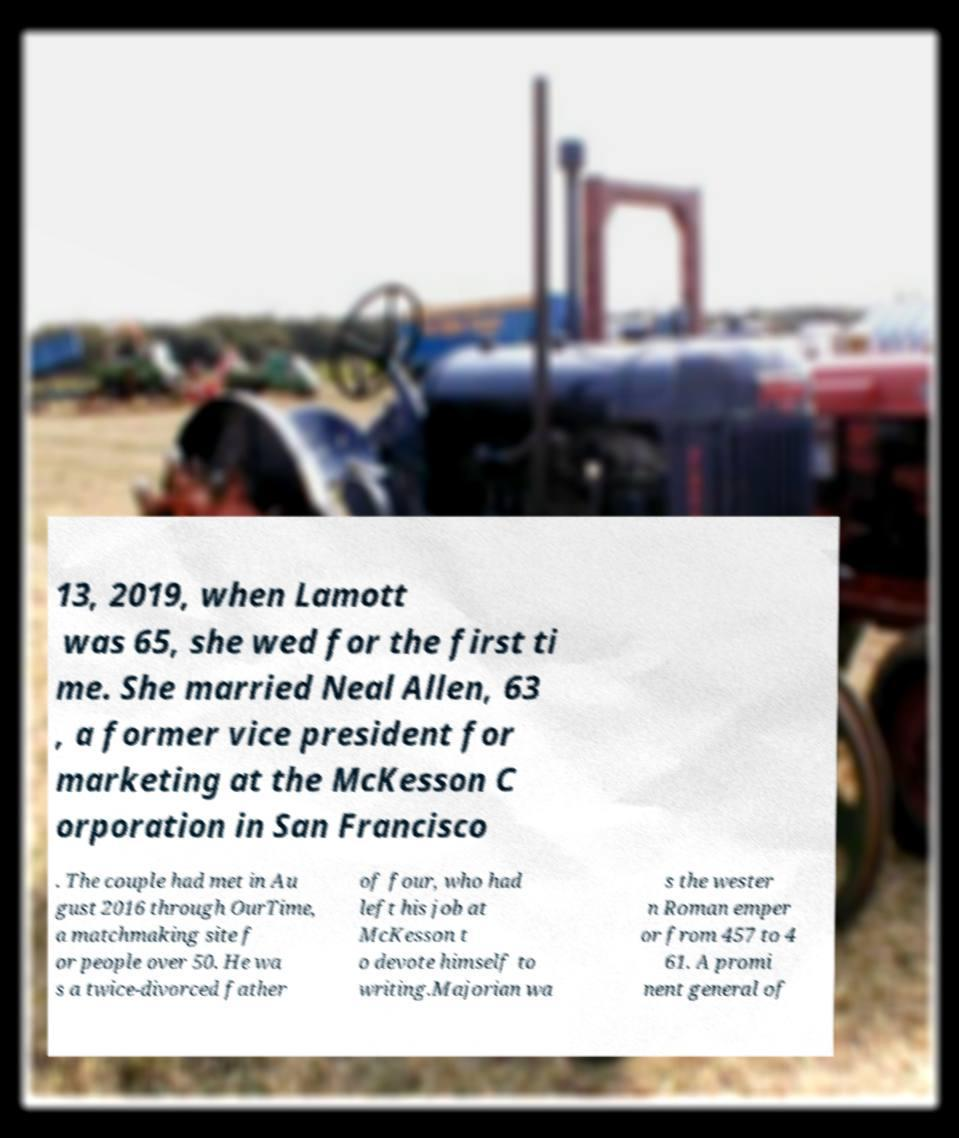Could you assist in decoding the text presented in this image and type it out clearly? 13, 2019, when Lamott was 65, she wed for the first ti me. She married Neal Allen, 63 , a former vice president for marketing at the McKesson C orporation in San Francisco . The couple had met in Au gust 2016 through OurTime, a matchmaking site f or people over 50. He wa s a twice-divorced father of four, who had left his job at McKesson t o devote himself to writing.Majorian wa s the wester n Roman emper or from 457 to 4 61. A promi nent general of 